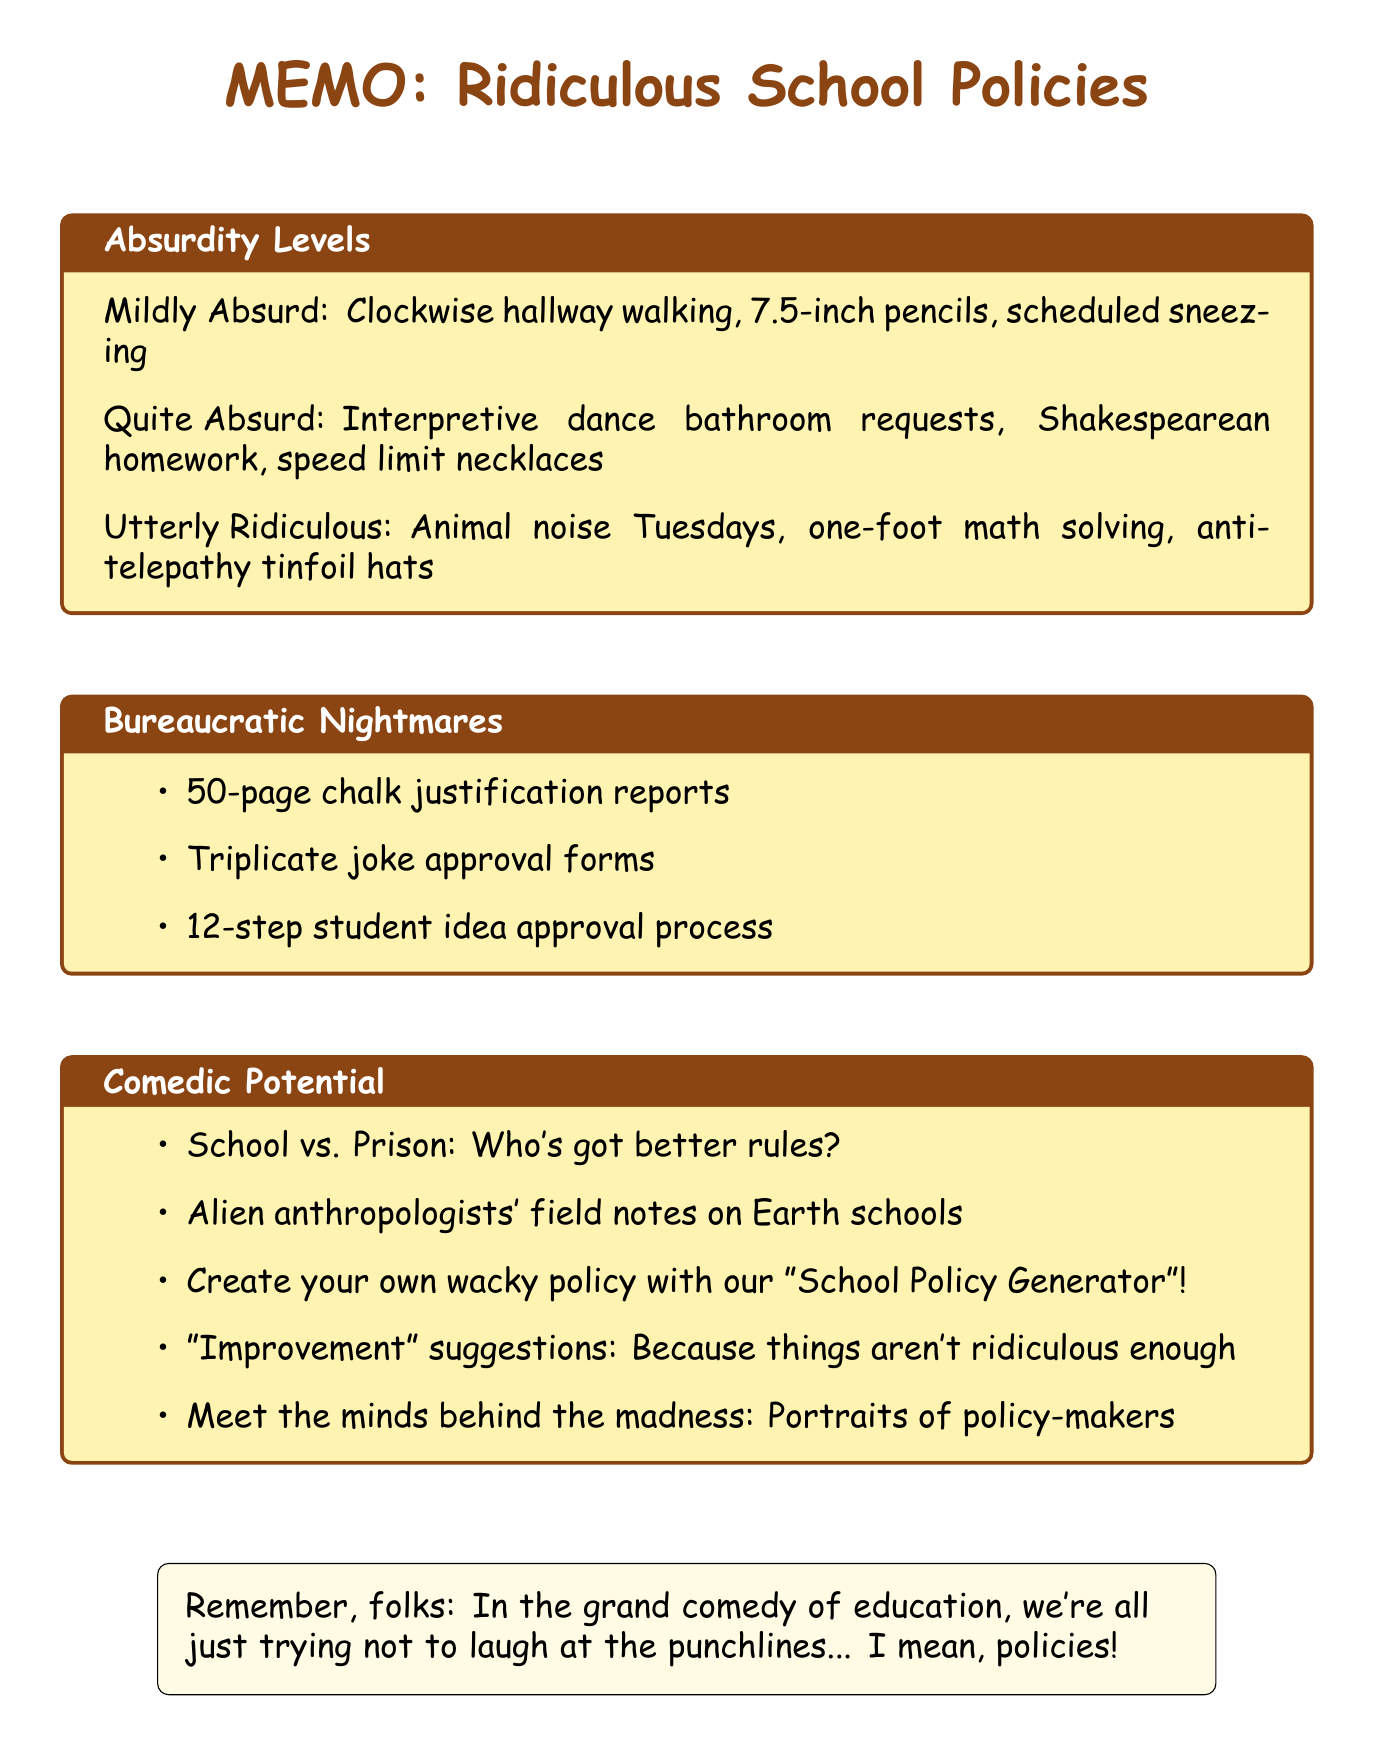What is the title of the memo? The title of the memo can be found at the top of the document, clearly stated.
Answer: Ridiculous School Policies: Audience Feedback Edition How many absurdity levels are mentioned? The document lists distinct categories of absurdity levels, clearly outlined.
Answer: 3 What is the policy from Lincoln High School? Each policy is attributed to a specific school, providing context for the absurdities listed.
Answer: Students must walk clockwise in hallways on odd-numbered days and counterclockwise on even-numbered days to 'improve traffic flow' What must teachers fill out before telling jokes? This involves specific bureaucratic procedures mentioned in the memo.
Answer: 'Joke Approval Form' What must students do during math problems at Hawkins Middle School? This reflects the specific details provided for the utterly ridiculous policies section.
Answer: Solve while standing on one foot How long must the chalk reports be? This is specified in the bureaucratic nightmares section detailing school bureaucracy requirements.
Answer: 50-page What is the comedic potential involving aliens? This question targets the creative suggestions provided in the comedic potential section of the memo.
Answer: Alien anthropologists' field notes on Earth schools What is the first policy listed under Quite Absurd? This asks for a specific policy from the grading of absurdity levels.
Answer: Students must use interpretive dance to ask for bathroom breaks 